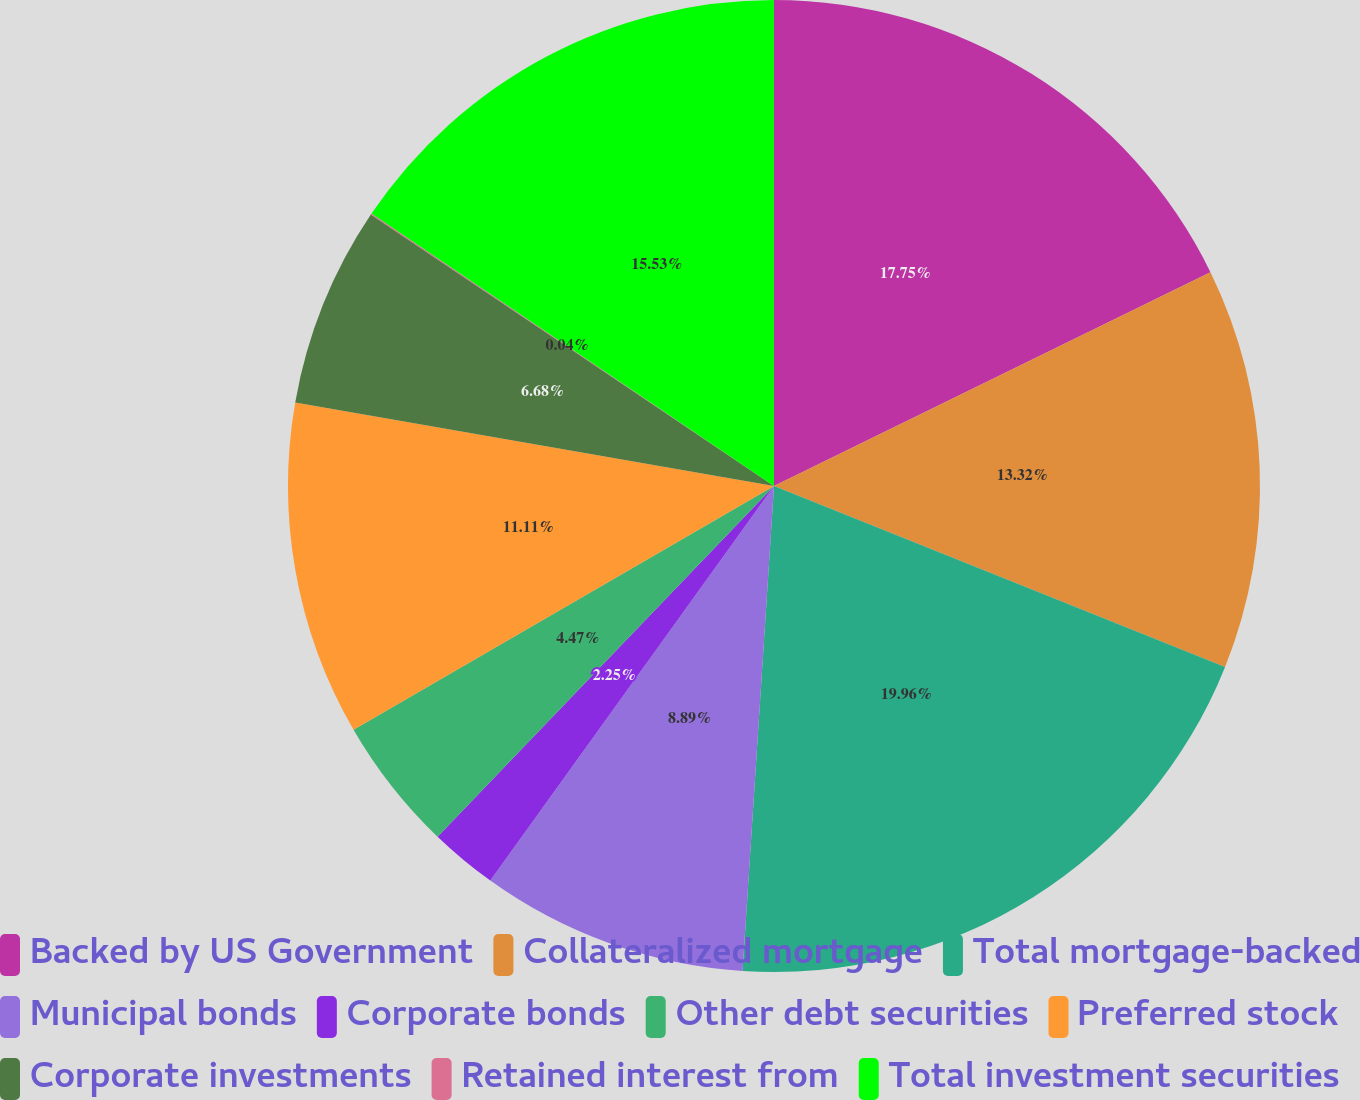Convert chart. <chart><loc_0><loc_0><loc_500><loc_500><pie_chart><fcel>Backed by US Government<fcel>Collateralized mortgage<fcel>Total mortgage-backed<fcel>Municipal bonds<fcel>Corporate bonds<fcel>Other debt securities<fcel>Preferred stock<fcel>Corporate investments<fcel>Retained interest from<fcel>Total investment securities<nl><fcel>17.75%<fcel>13.32%<fcel>19.96%<fcel>8.89%<fcel>2.25%<fcel>4.47%<fcel>11.11%<fcel>6.68%<fcel>0.04%<fcel>15.53%<nl></chart> 